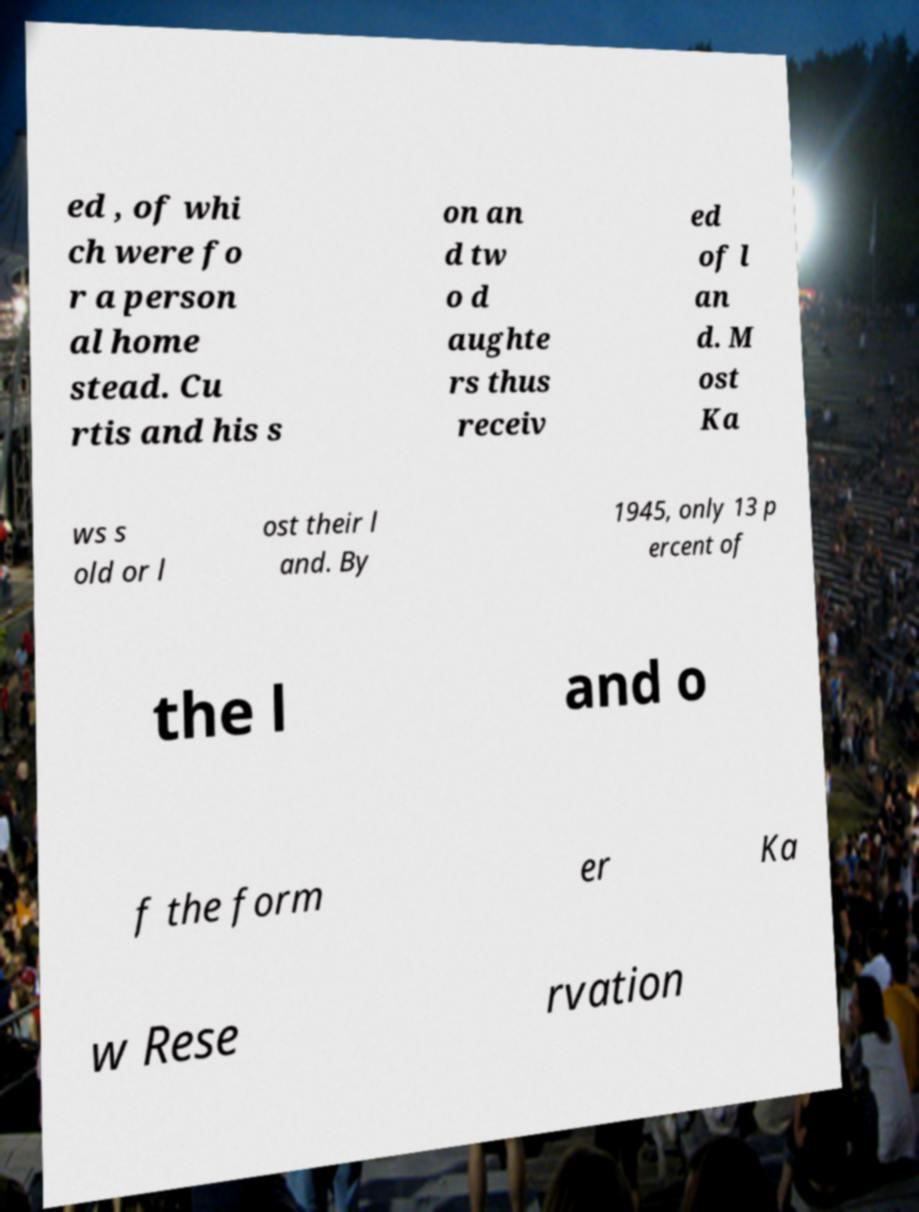I need the written content from this picture converted into text. Can you do that? ed , of whi ch were fo r a person al home stead. Cu rtis and his s on an d tw o d aughte rs thus receiv ed of l an d. M ost Ka ws s old or l ost their l and. By 1945, only 13 p ercent of the l and o f the form er Ka w Rese rvation 